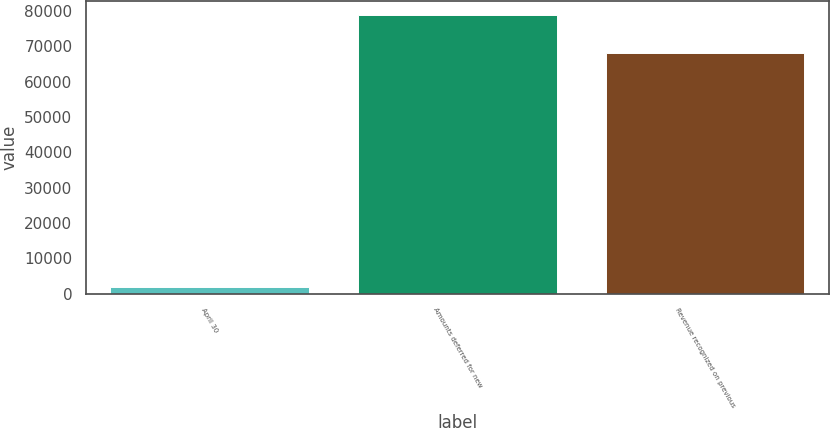<chart> <loc_0><loc_0><loc_500><loc_500><bar_chart><fcel>April 30<fcel>Amounts deferred for new<fcel>Revenue recognized on previous<nl><fcel>2006<fcel>78900<fcel>67978<nl></chart> 